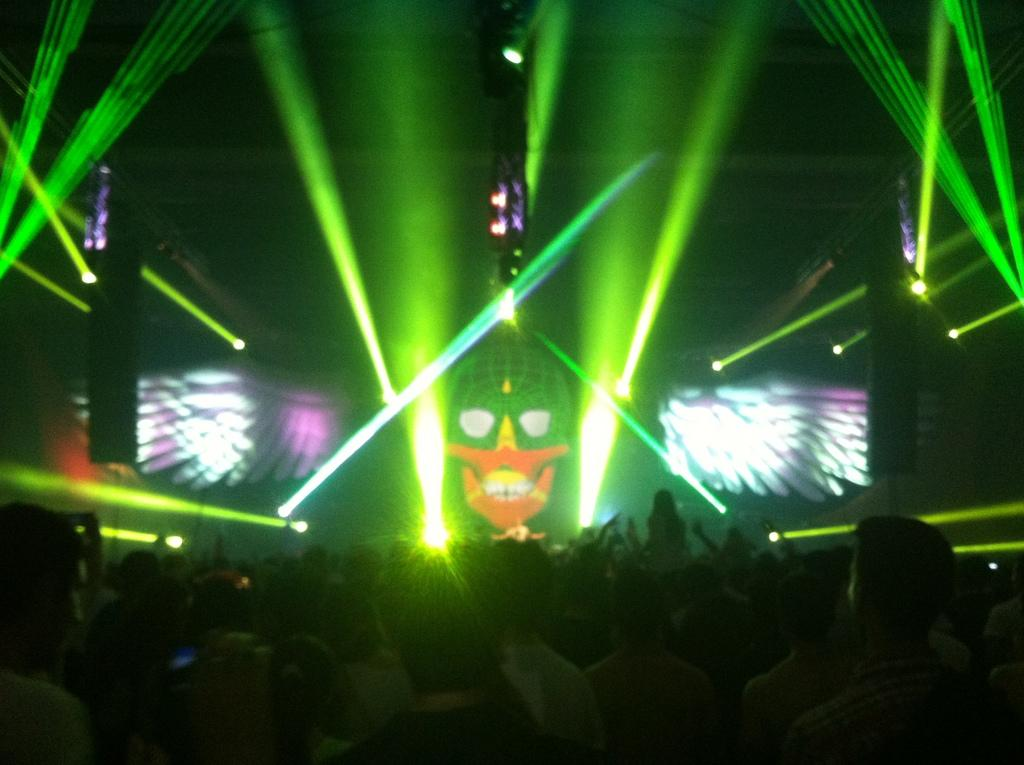Who or what can be seen in the image? There are people in the image. What objects are present that emit light? There are lights in the image. What type of electronic devices are visible? There are screens in the image. Is there any symbol or object related to mortality in the image? Yes, there is a skull in the image. What type of bucket is being used to surprise the people in the image? There is no bucket present in the image, and no one is being surprised. 